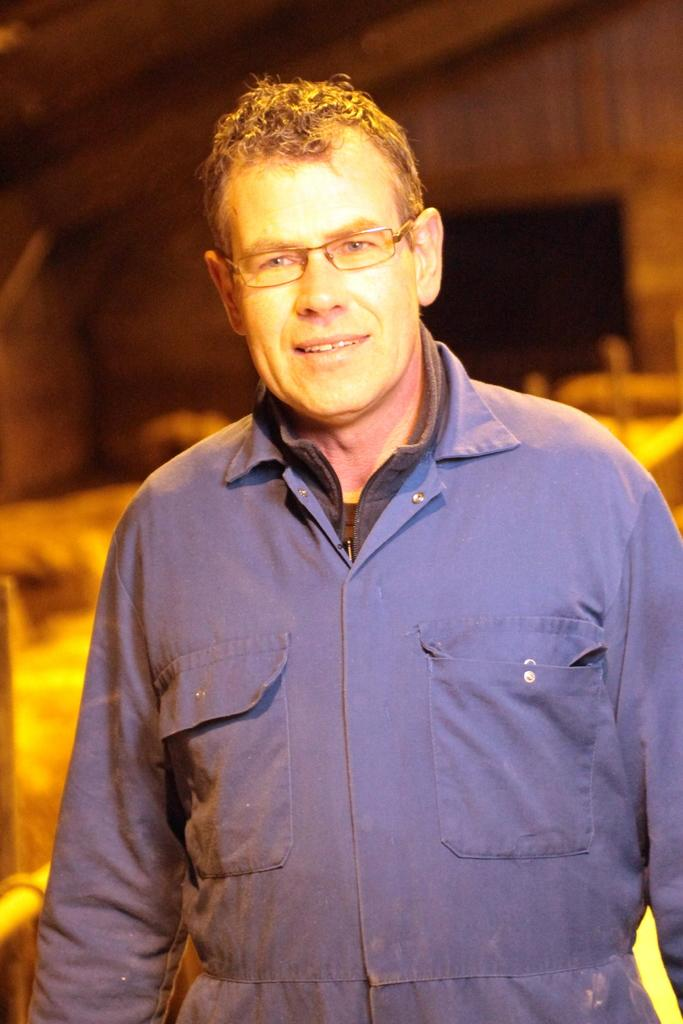Who is present in the image? There is a man in the image. What is the man doing in the image? The man is smiling in the image. What type of headgear is the man wearing in the image? There is no headgear visible in the image; the man is not wearing anything on his head. 